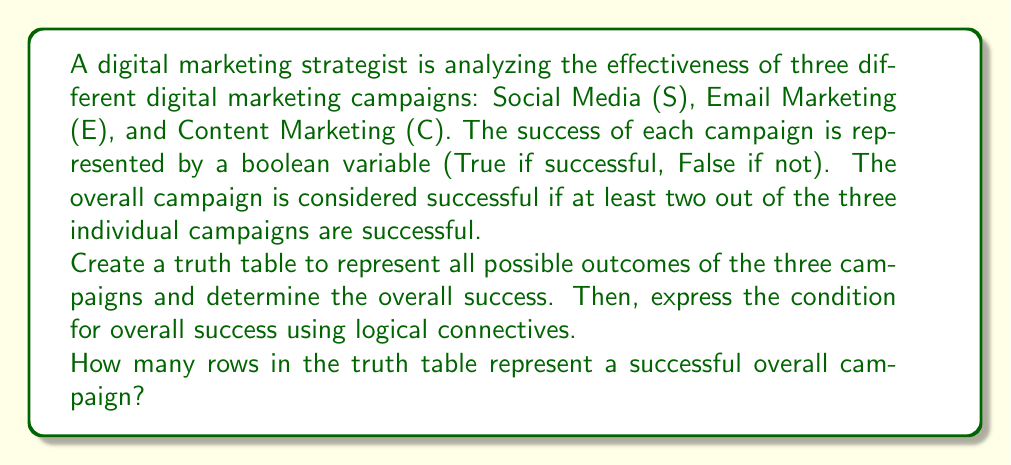Can you answer this question? To solve this problem, we need to create a truth table and use logical connectives to express the success condition. Let's break it down step by step:

1. Create the truth table:
   We have three variables (S, E, C), so our truth table will have $2^3 = 8$ rows.

   $$
   \begin{array}{|c|c|c|c|}
   \hline
   S & E & C & \text{Overall Success} \\
   \hline
   T & T & T & T \\
   T & T & F & T \\
   T & F & T & T \\
   T & F & F & F \\
   F & T & T & T \\
   F & T & F & F \\
   F & F & T & F \\
   F & F & F & F \\
   \hline
   \end{array}
   $$

2. Express the condition for overall success using logical connectives:
   The overall campaign is successful if at least two out of the three individual campaigns are successful. We can express this using the following logical expression:

   $$(S \land E) \lor (S \land C) \lor (E \land C)$$

   Where $\land$ represents AND, and $\lor$ represents OR.

3. Count the number of rows representing a successful overall campaign:
   Looking at the truth table, we can see that there are 4 rows where the overall success is True (T).

Therefore, there are 4 rows in the truth table that represent a successful overall campaign.
Answer: 4 